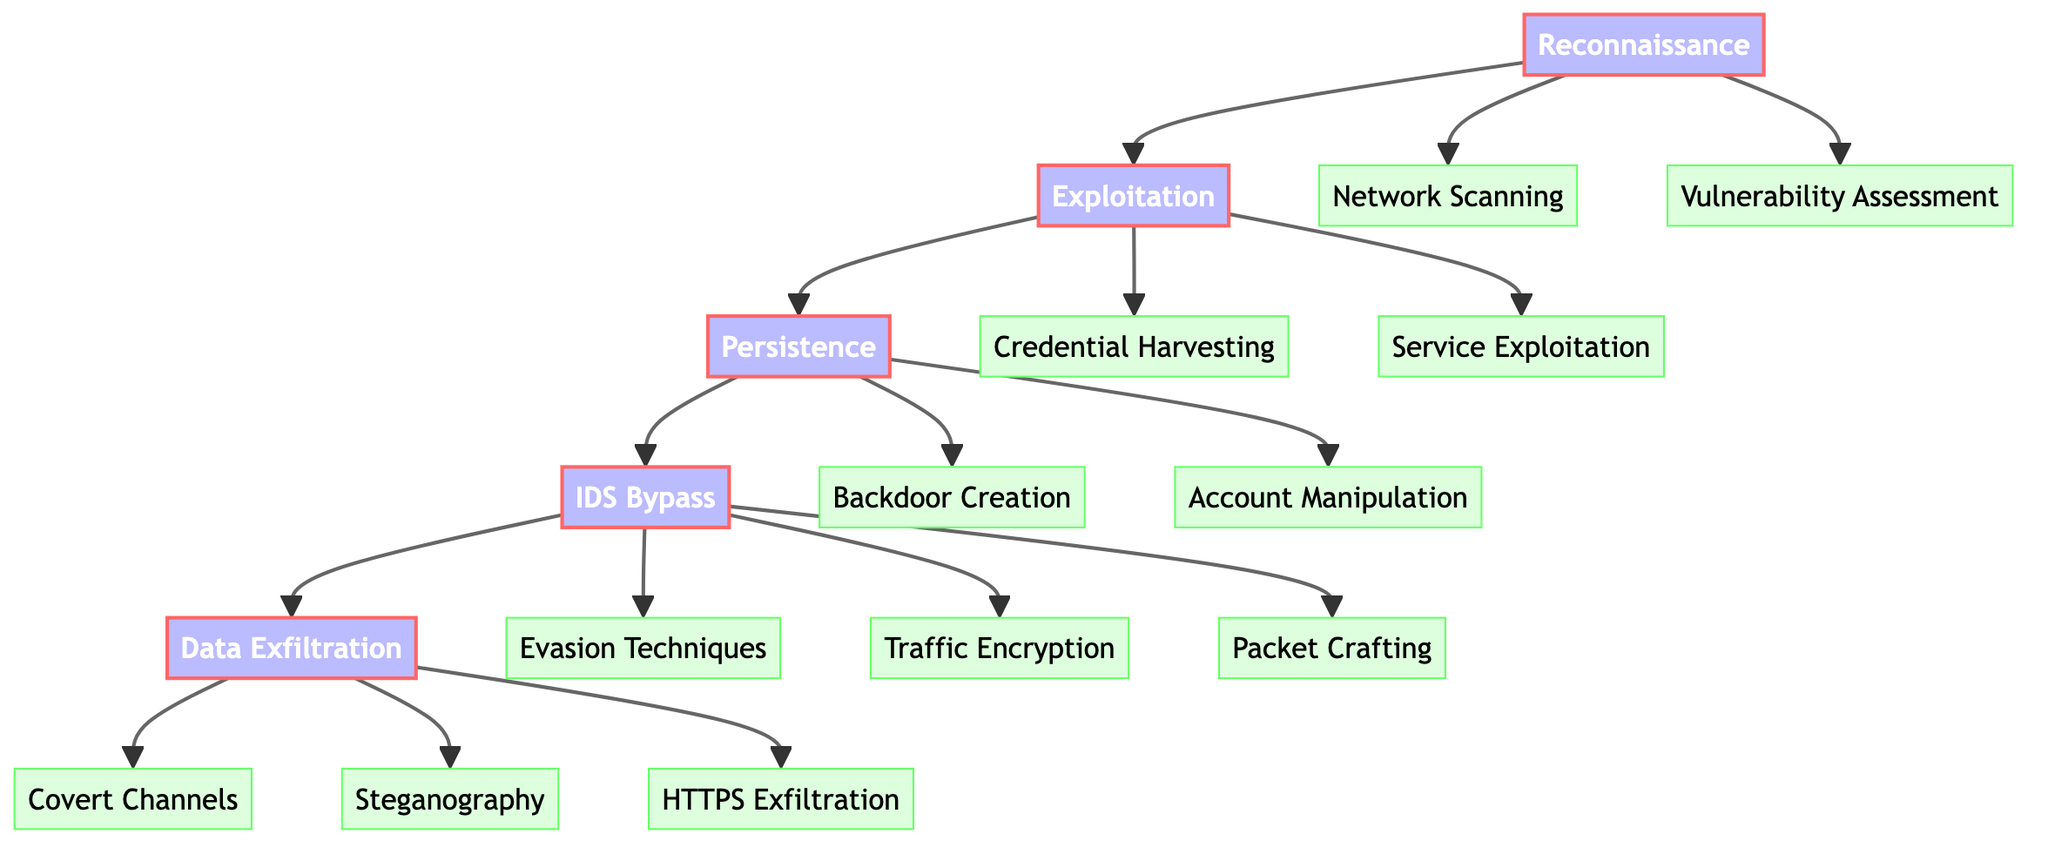What is the first step in the diagram? The diagram starts with the step labeled "Reconnaissance," which is the first step in the clinical pathway.
Answer: Reconnaissance How many sub-steps are there under "Persistence"? Under the "Persistence" step, there are two sub-steps listed: "Backdoor Creation" and "Account Manipulation." Therefore, the total number of sub-steps is two.
Answer: 2 What tools are used for "Traffic Encryption"? The sub-step "Traffic Encryption" specifies two tools: "Stunnel" and "OpenSSL," which are identified as the tools for this action.
Answer: Stunnel, OpenSSL Which step follows "Exploitation"? From the flow of the diagram, the step that directly follows "Exploitation" is "Persistence," indicating the progression in the clinical pathway.
Answer: Persistence What is the objective of "Evasion Techniques"? The sub-step "Evasion Techniques" has the objective of "Avoid detection by IDS rules," which explains what this action aims to achieve.
Answer: Avoid detection by IDS rules How many main steps are in total in the diagram? The diagram shows a total of five main steps: "Reconnaissance," "Exploitation," "Persistence," "IDS Bypass," and "Data Exfiltration," so the total count is five.
Answer: 5 Which sub-step involves “crafting packets”? The sub-step that mentions "crafting packets" is labeled "Packet Crafting," making it the specific sub-step associated with this action.
Answer: Packet Crafting What is the second sub-step in the "IDS Bypass" step? The second sub-step under "IDS Bypass" is "Traffic Encryption," which is the middle action listed within that main step.
Answer: Traffic Encryption 